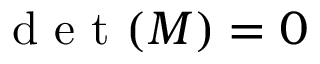Convert formula to latex. <formula><loc_0><loc_0><loc_500><loc_500>d e t ( M ) = 0</formula> 